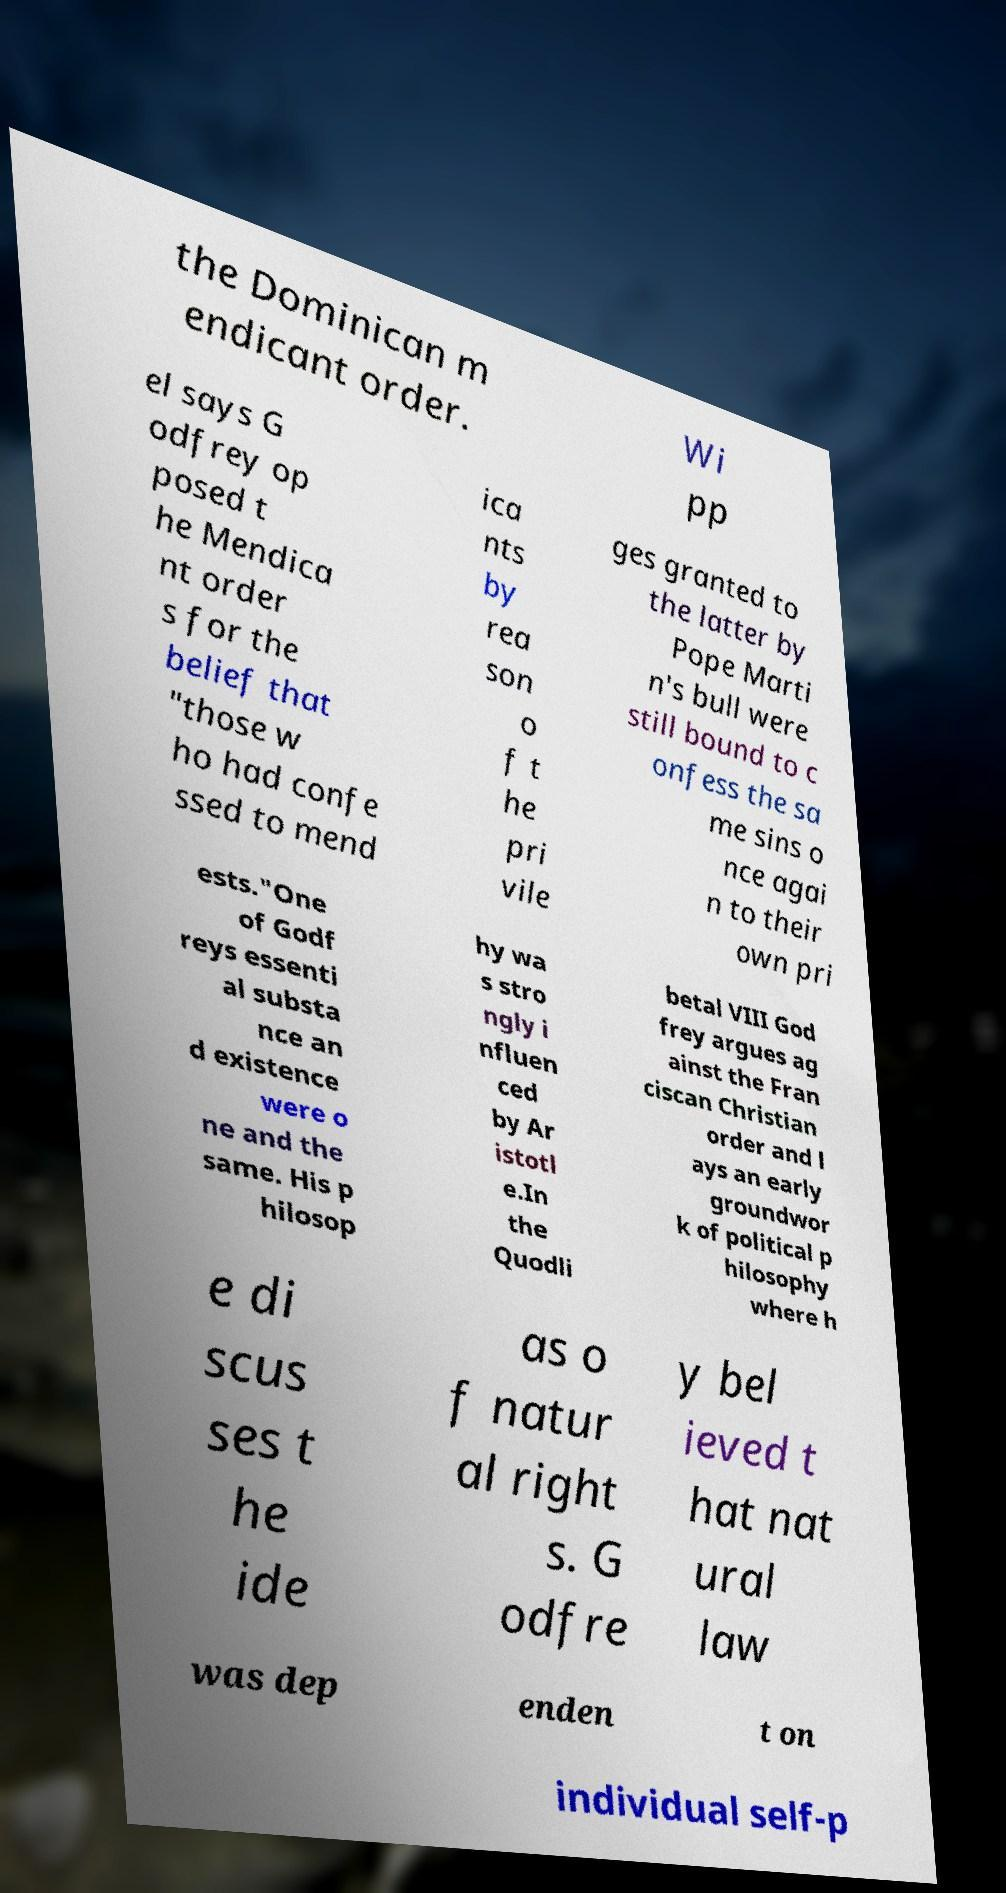I need the written content from this picture converted into text. Can you do that? the Dominican m endicant order. Wi pp el says G odfrey op posed t he Mendica nt order s for the belief that "those w ho had confe ssed to mend ica nts by rea son o f t he pri vile ges granted to the latter by Pope Marti n's bull were still bound to c onfess the sa me sins o nce agai n to their own pri ests."One of Godf reys essenti al substa nce an d existence were o ne and the same. His p hilosop hy wa s stro ngly i nfluen ced by Ar istotl e.In the Quodli betal VIII God frey argues ag ainst the Fran ciscan Christian order and l ays an early groundwor k of political p hilosophy where h e di scus ses t he ide as o f natur al right s. G odfre y bel ieved t hat nat ural law was dep enden t on individual self-p 